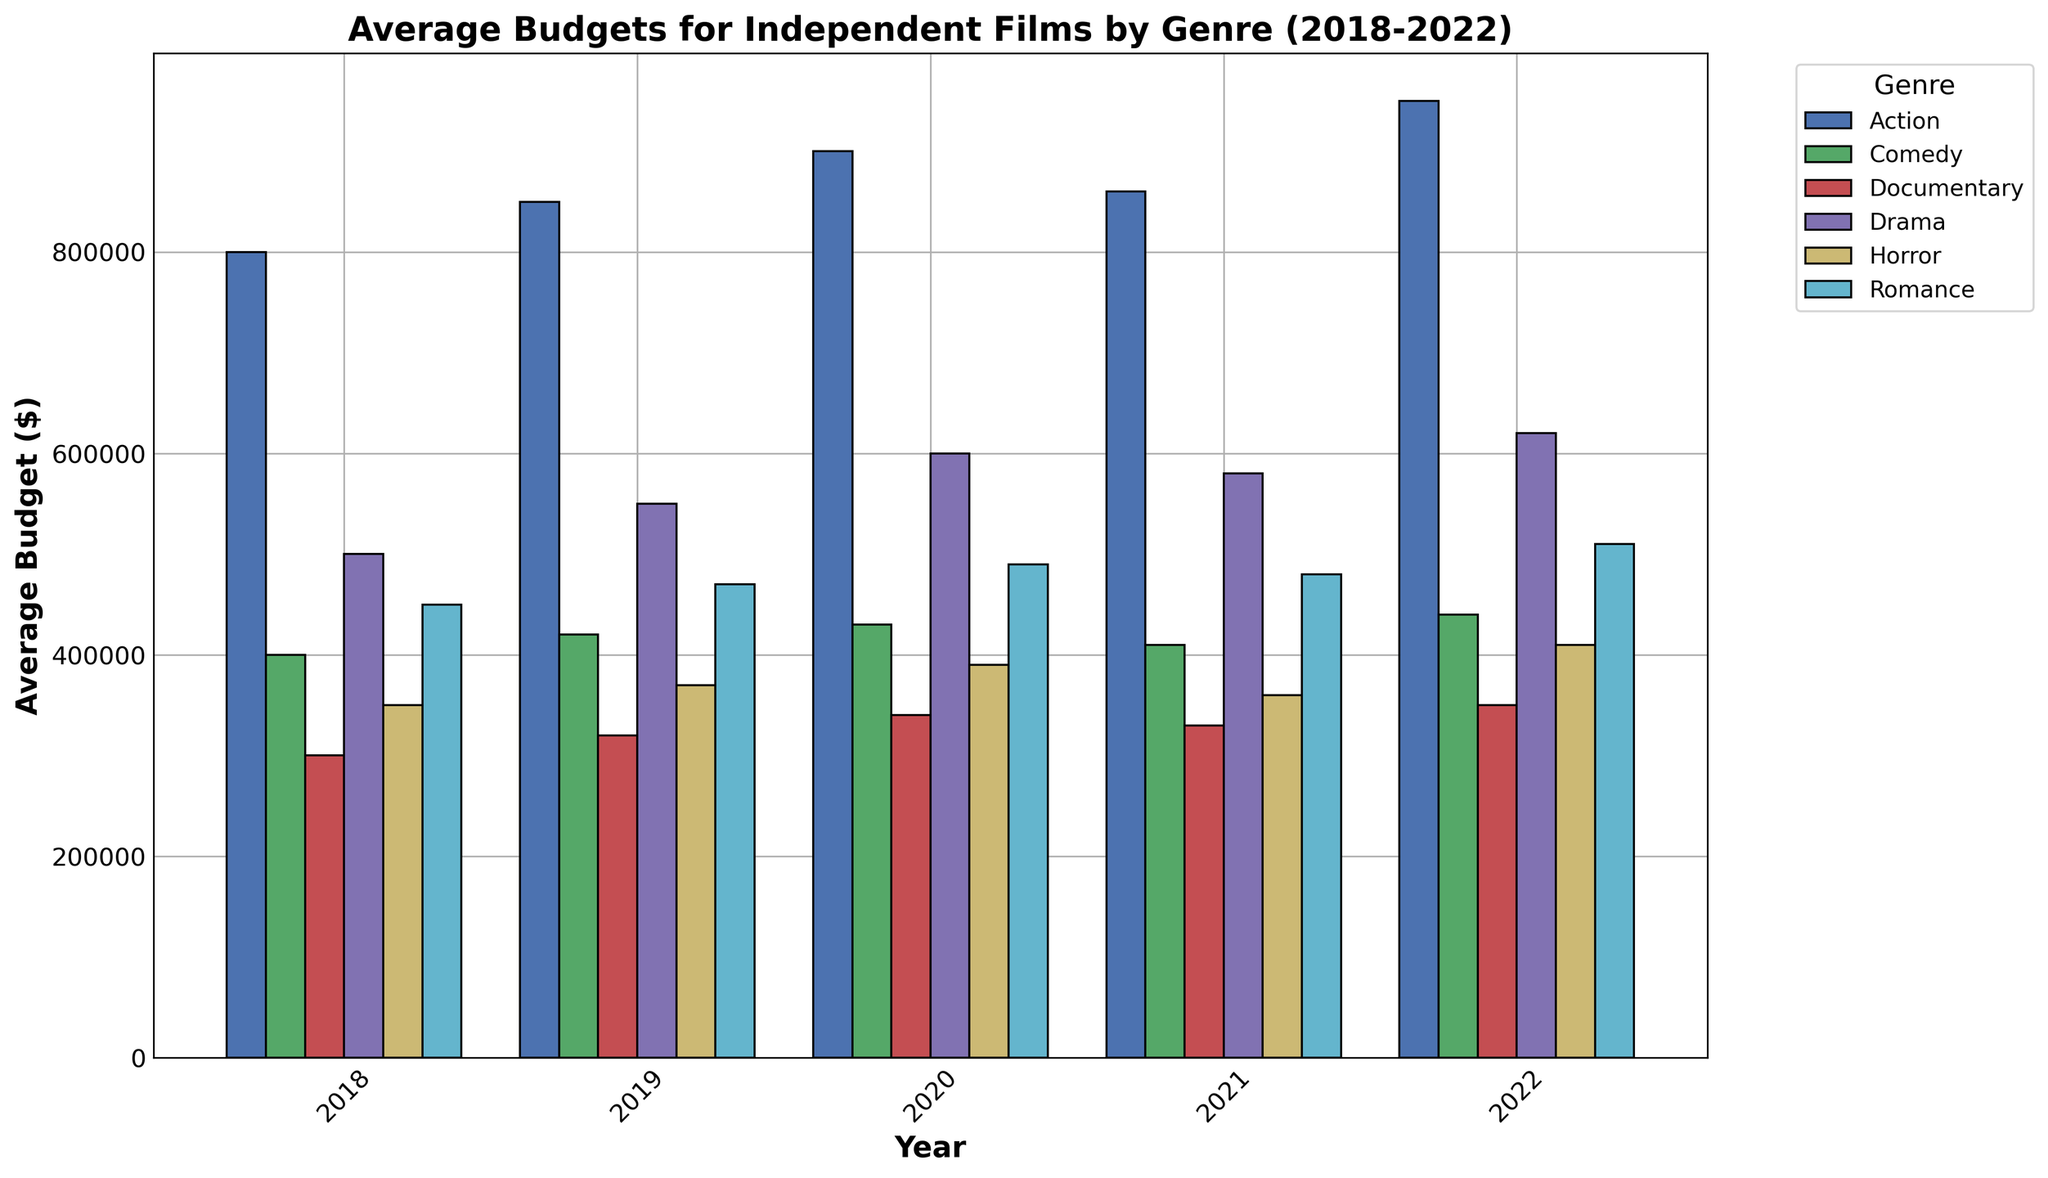What was the average budget for Drama films in 2020? First, locate the bar corresponding to Drama in 2020. Read the height of the bar to find the average budget.
Answer: $600,000 Which genre had the highest average budget in 2022? Locate the bars for 2022 and find the tallest one. Action has the highest bar, indicating the highest average budget.
Answer: Action How did the average budget for Horror films change from 2018 to 2019? Compare the heights of the Horror bars for 2018 and 2019. The budget increased from $350,000 to $370,000.
Answer: Increased What is the total average budget for Comedy films from 2018 to 2022? Sum the heights of the Comedy bars from 2018 to 2022: 400,000 + 420,000 + 430,000 + 410,000 + 440,000 = 2,100,000.
Answer: $2,100,000 Which year saw the lowest average budget for Documentary films? Look at the Documentary bars across all years. The lowest bar is in 2018.
Answer: 2018 What is the difference in average budget between Action and Romance films in 2021? Find the heights of the Action and Romance bars for 2021: 860,000 (Action) and 480,000 (Romance). Calculate the difference: 860,000 - 480,000 = 380,000.
Answer: $380,000 In which year did Drama films have the highest average budget? Look at the heights of the Drama bars across all the years. The tallest bar is in 2022.
Answer: 2022 Compare the average budgets of Comedy films in 2019 and 2020. Which was higher? Find the heights of the Comedy bars for 2019 and 2020. The 2020 bar is taller than the 2019 bar, indicating a higher budget.
Answer: 2020 What is the average budget for Documentary films over the 5 years? Sum the heights of the Documentary bars and divide by 5: (300,000 + 320,000 + 340,000 + 330,000 + 350,000) / 5 = 328,000.
Answer: $328,000 